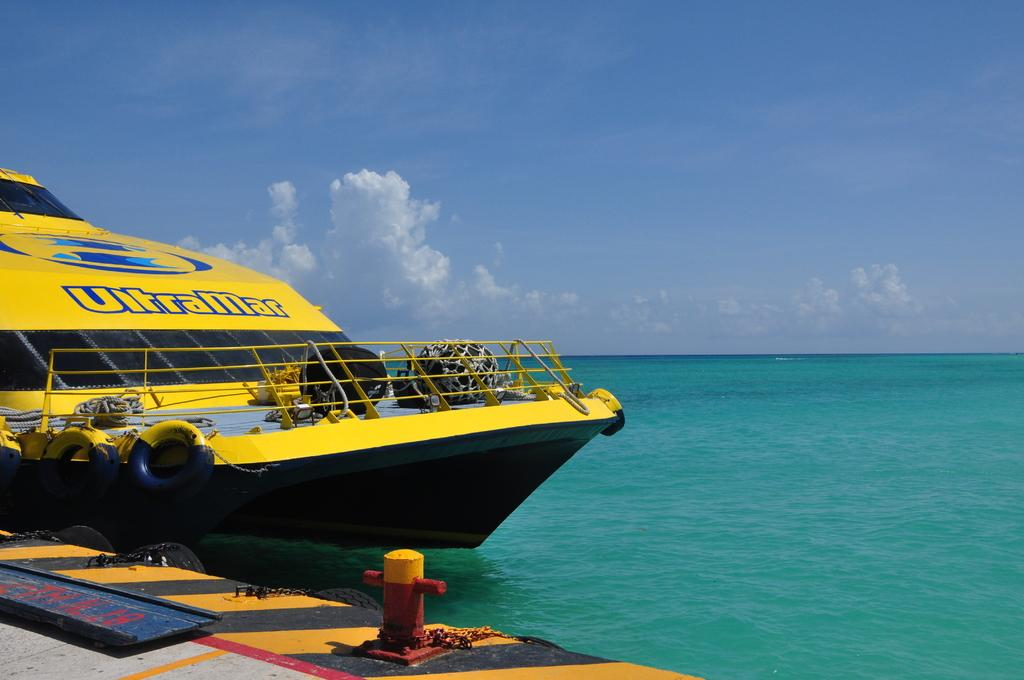<image>
Provide a brief description of the given image. An UltraMar boat is bright yellow and is at the dock. 